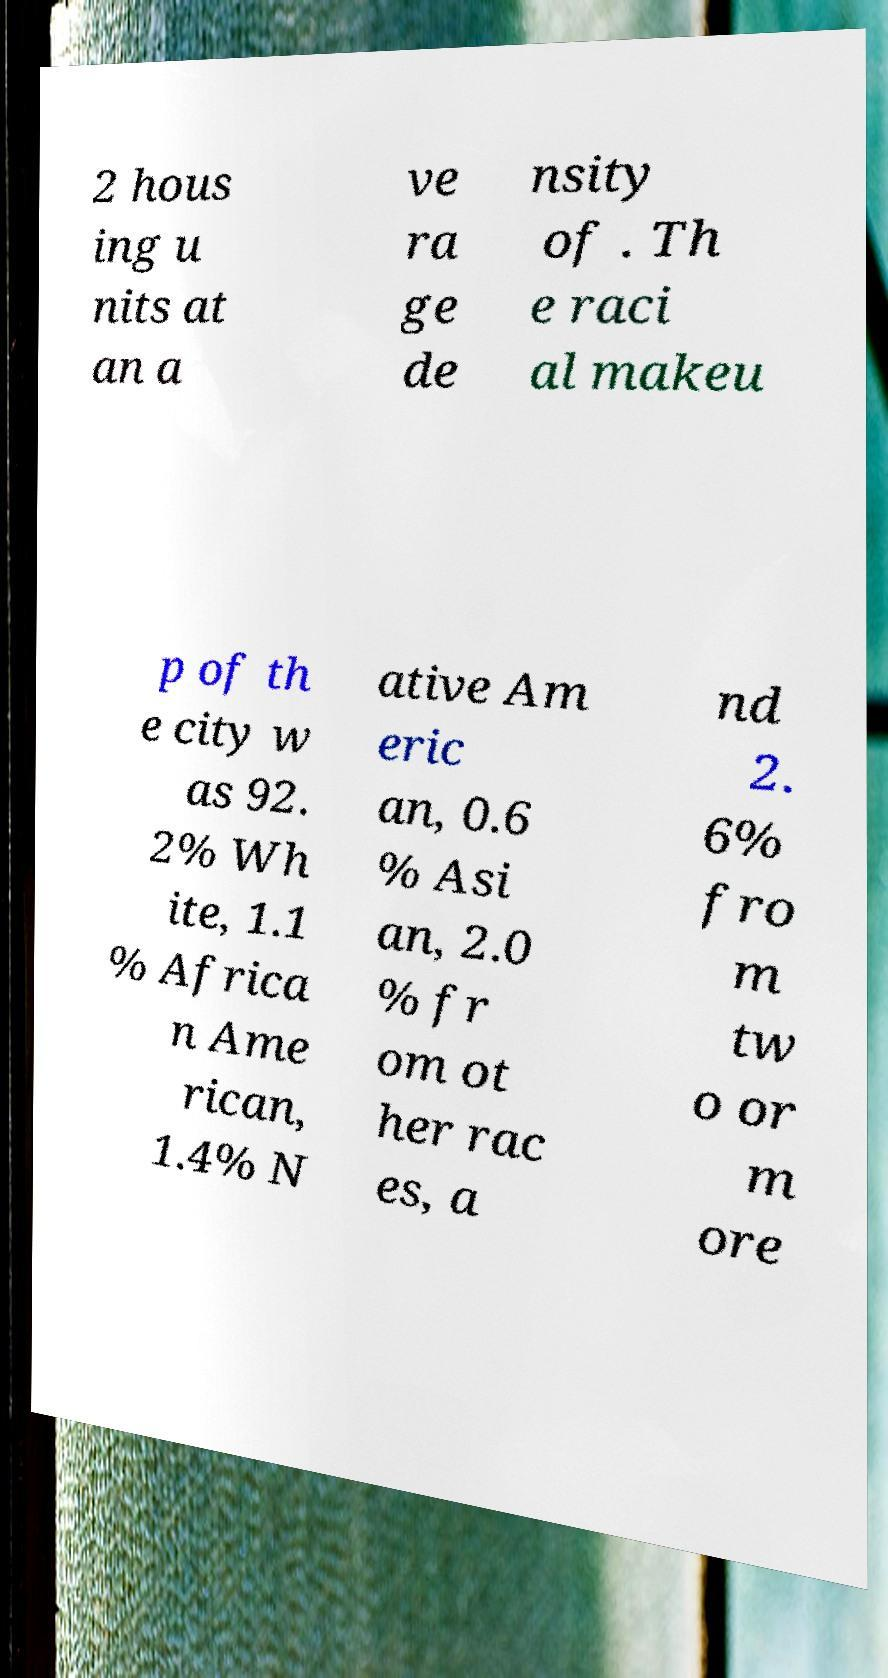Can you read and provide the text displayed in the image?This photo seems to have some interesting text. Can you extract and type it out for me? 2 hous ing u nits at an a ve ra ge de nsity of . Th e raci al makeu p of th e city w as 92. 2% Wh ite, 1.1 % Africa n Ame rican, 1.4% N ative Am eric an, 0.6 % Asi an, 2.0 % fr om ot her rac es, a nd 2. 6% fro m tw o or m ore 